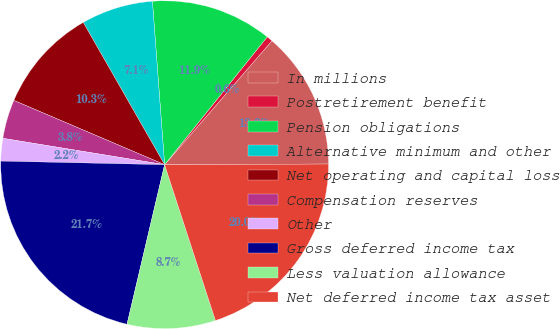<chart> <loc_0><loc_0><loc_500><loc_500><pie_chart><fcel>In millions<fcel>Postretirement benefit<fcel>Pension obligations<fcel>Alternative minimum and other<fcel>Net operating and capital loss<fcel>Compensation reserves<fcel>Other<fcel>Gross deferred income tax<fcel>Less valuation allowance<fcel>Net deferred income tax asset<nl><fcel>13.57%<fcel>0.6%<fcel>11.95%<fcel>7.08%<fcel>10.32%<fcel>3.84%<fcel>2.22%<fcel>21.67%<fcel>8.7%<fcel>20.05%<nl></chart> 